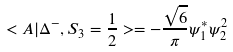Convert formula to latex. <formula><loc_0><loc_0><loc_500><loc_500>< A | \Delta ^ { - } , S _ { 3 } = \frac { 1 } { 2 } > = - \frac { \sqrt { 6 } } { \pi } \psi _ { 1 } ^ { * } \psi _ { 2 } ^ { 2 }</formula> 